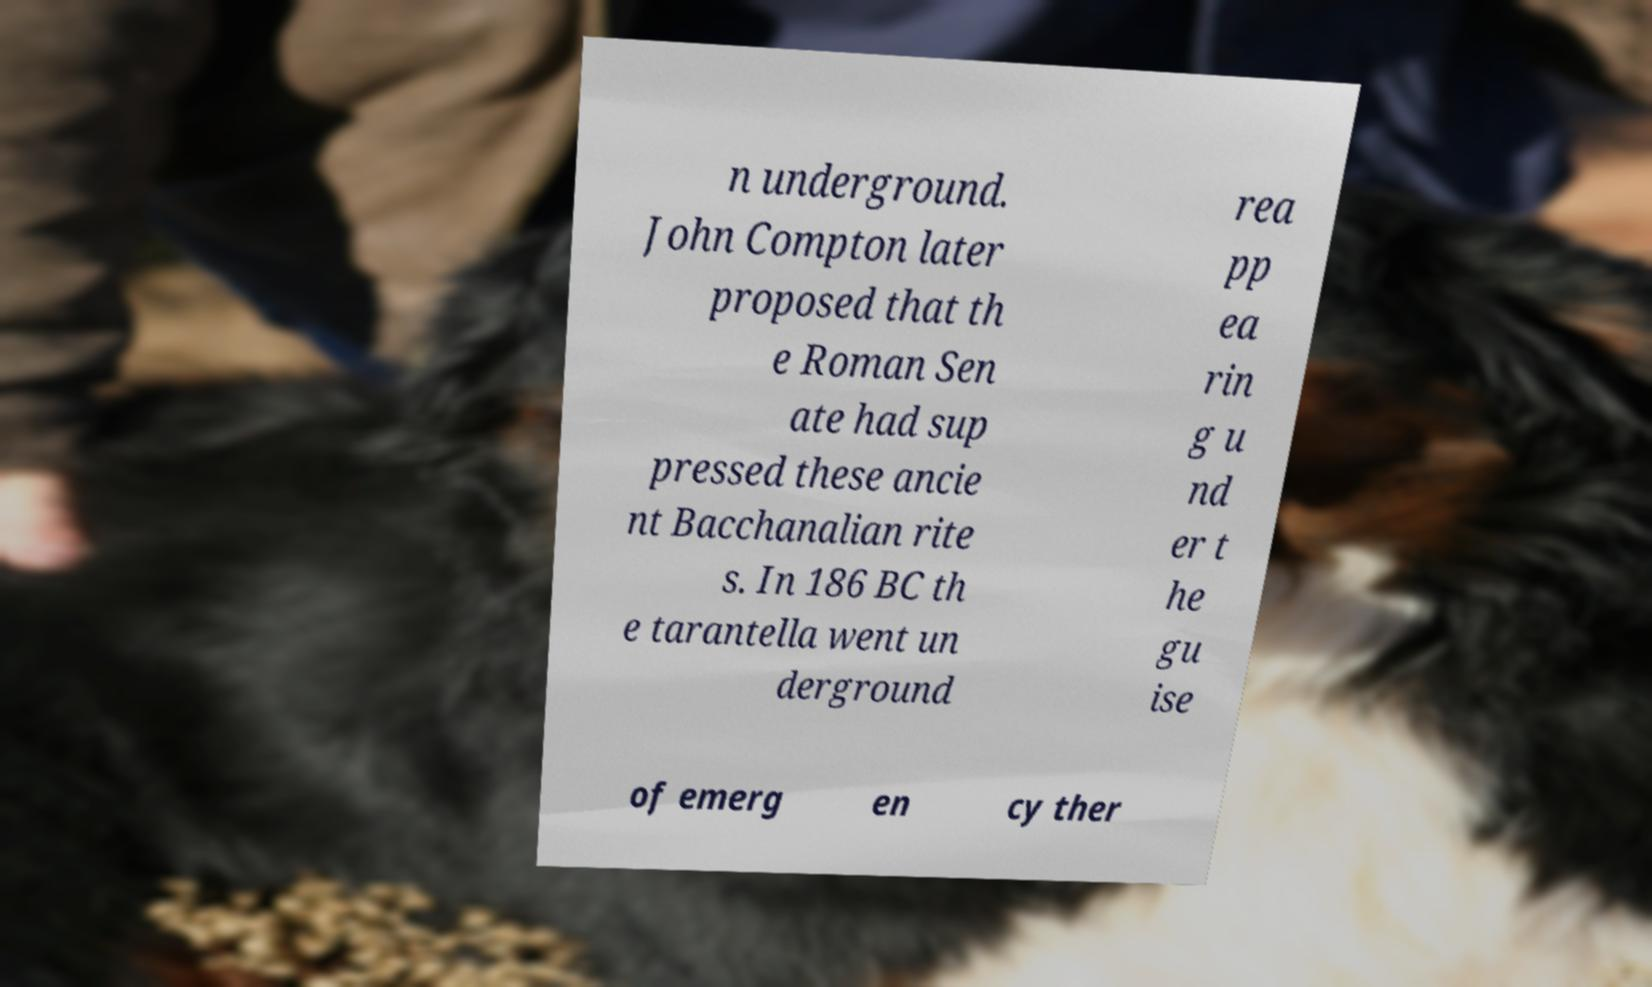Could you assist in decoding the text presented in this image and type it out clearly? n underground. John Compton later proposed that th e Roman Sen ate had sup pressed these ancie nt Bacchanalian rite s. In 186 BC th e tarantella went un derground rea pp ea rin g u nd er t he gu ise of emerg en cy ther 